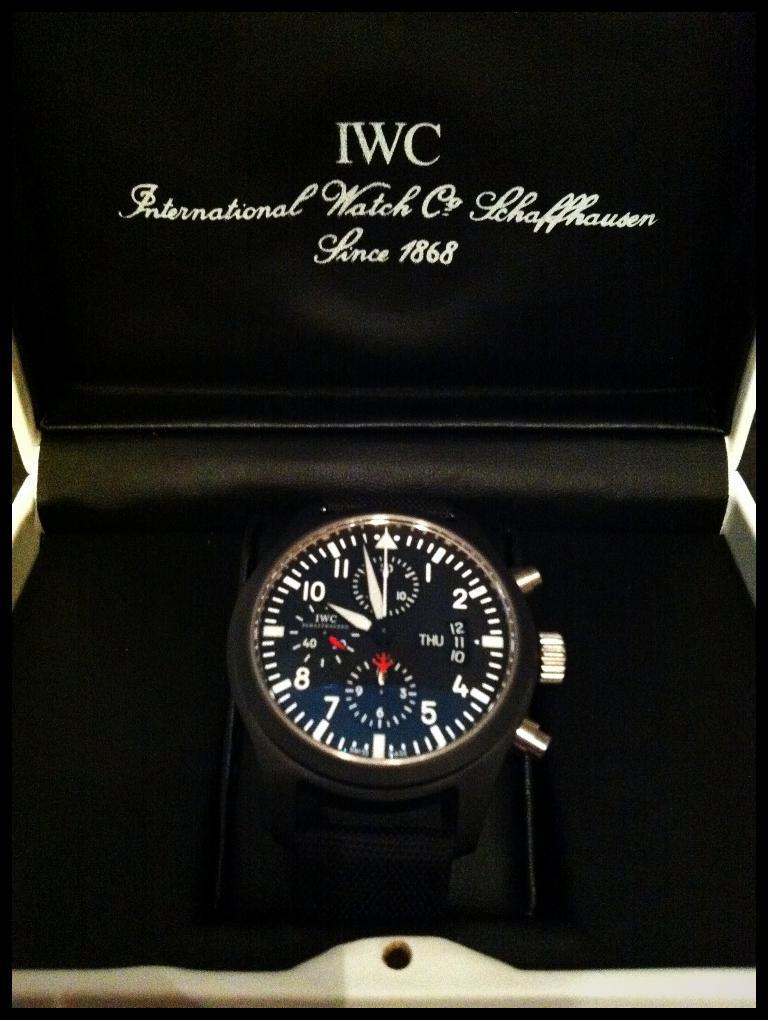Describe this image in one or two sentences. This is a zoomed in picture. In the center we can see a watch placed in a box. At the top we can see the text and the numbers on the box and we can see the borders on the image. 